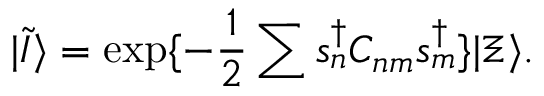<formula> <loc_0><loc_0><loc_500><loc_500>| \tilde { I } \rangle = \exp \{ - \frac { 1 } { 2 } \sum s _ { n } ^ { \dag } C _ { n m } s _ { m } ^ { \dag } \} | \Xi \rangle .</formula> 